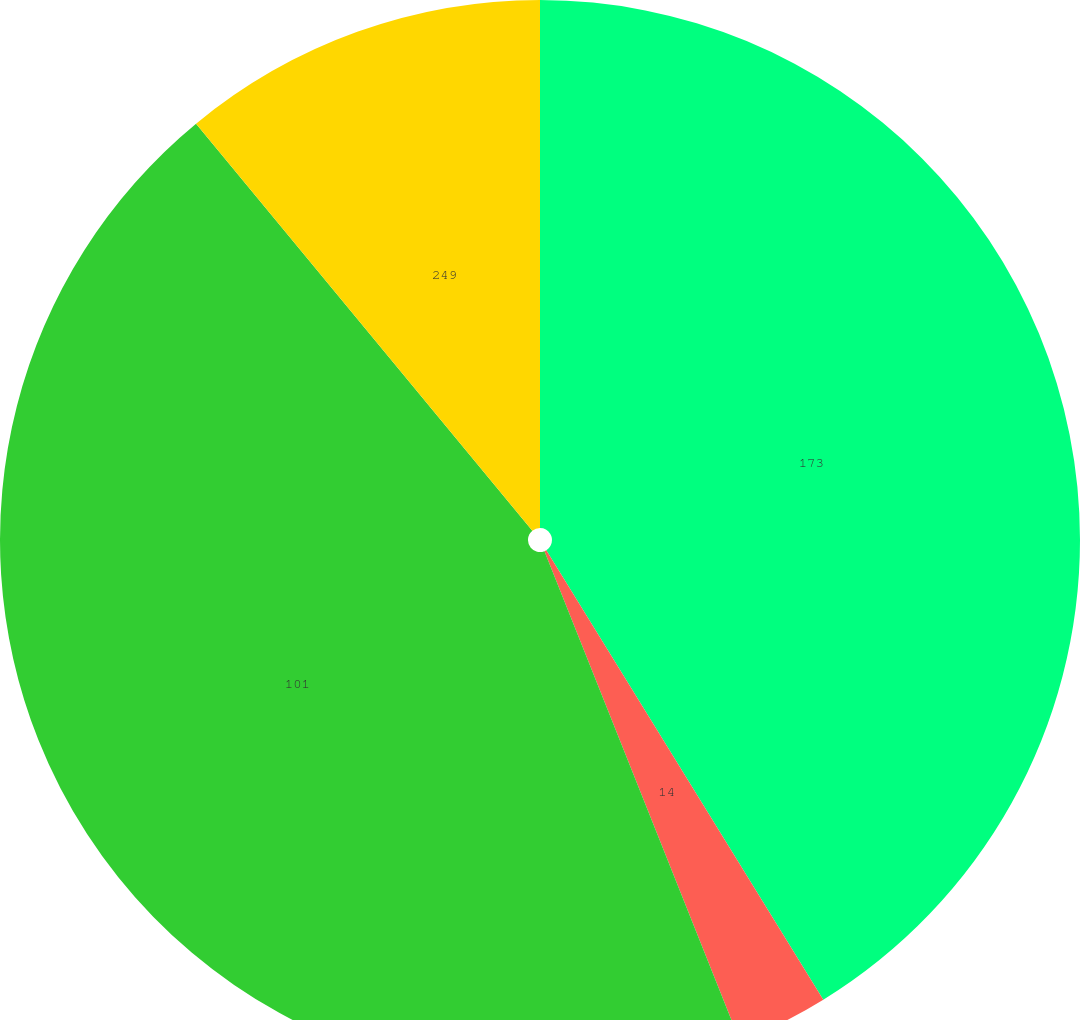<chart> <loc_0><loc_0><loc_500><loc_500><pie_chart><fcel>173<fcel>14<fcel>101<fcel>249<nl><fcel>41.21%<fcel>2.75%<fcel>45.05%<fcel>10.99%<nl></chart> 